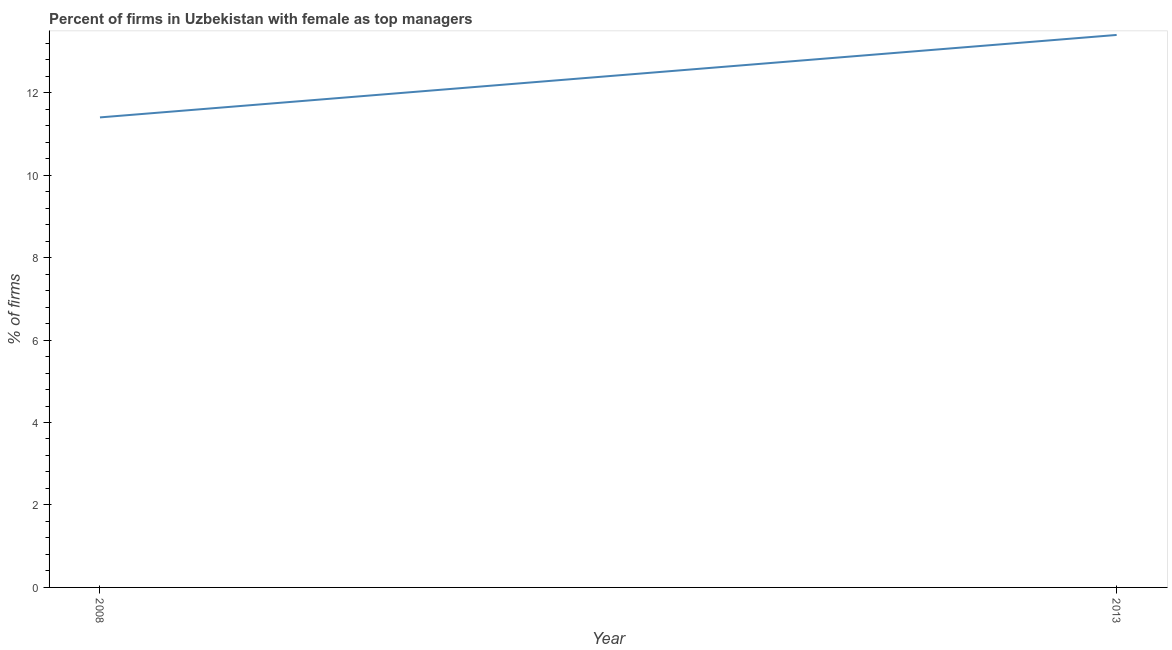What is the percentage of firms with female as top manager in 2013?
Provide a short and direct response. 13.4. Across all years, what is the minimum percentage of firms with female as top manager?
Keep it short and to the point. 11.4. What is the sum of the percentage of firms with female as top manager?
Your answer should be compact. 24.8. What is the difference between the percentage of firms with female as top manager in 2008 and 2013?
Offer a terse response. -2. What is the average percentage of firms with female as top manager per year?
Make the answer very short. 12.4. What is the median percentage of firms with female as top manager?
Provide a succinct answer. 12.4. What is the ratio of the percentage of firms with female as top manager in 2008 to that in 2013?
Offer a terse response. 0.85. In how many years, is the percentage of firms with female as top manager greater than the average percentage of firms with female as top manager taken over all years?
Keep it short and to the point. 1. Does the percentage of firms with female as top manager monotonically increase over the years?
Your answer should be very brief. Yes. Are the values on the major ticks of Y-axis written in scientific E-notation?
Offer a very short reply. No. Does the graph contain any zero values?
Offer a terse response. No. Does the graph contain grids?
Offer a very short reply. No. What is the title of the graph?
Provide a succinct answer. Percent of firms in Uzbekistan with female as top managers. What is the label or title of the Y-axis?
Your response must be concise. % of firms. What is the % of firms in 2008?
Offer a terse response. 11.4. What is the % of firms in 2013?
Offer a terse response. 13.4. What is the difference between the % of firms in 2008 and 2013?
Make the answer very short. -2. What is the ratio of the % of firms in 2008 to that in 2013?
Offer a very short reply. 0.85. 